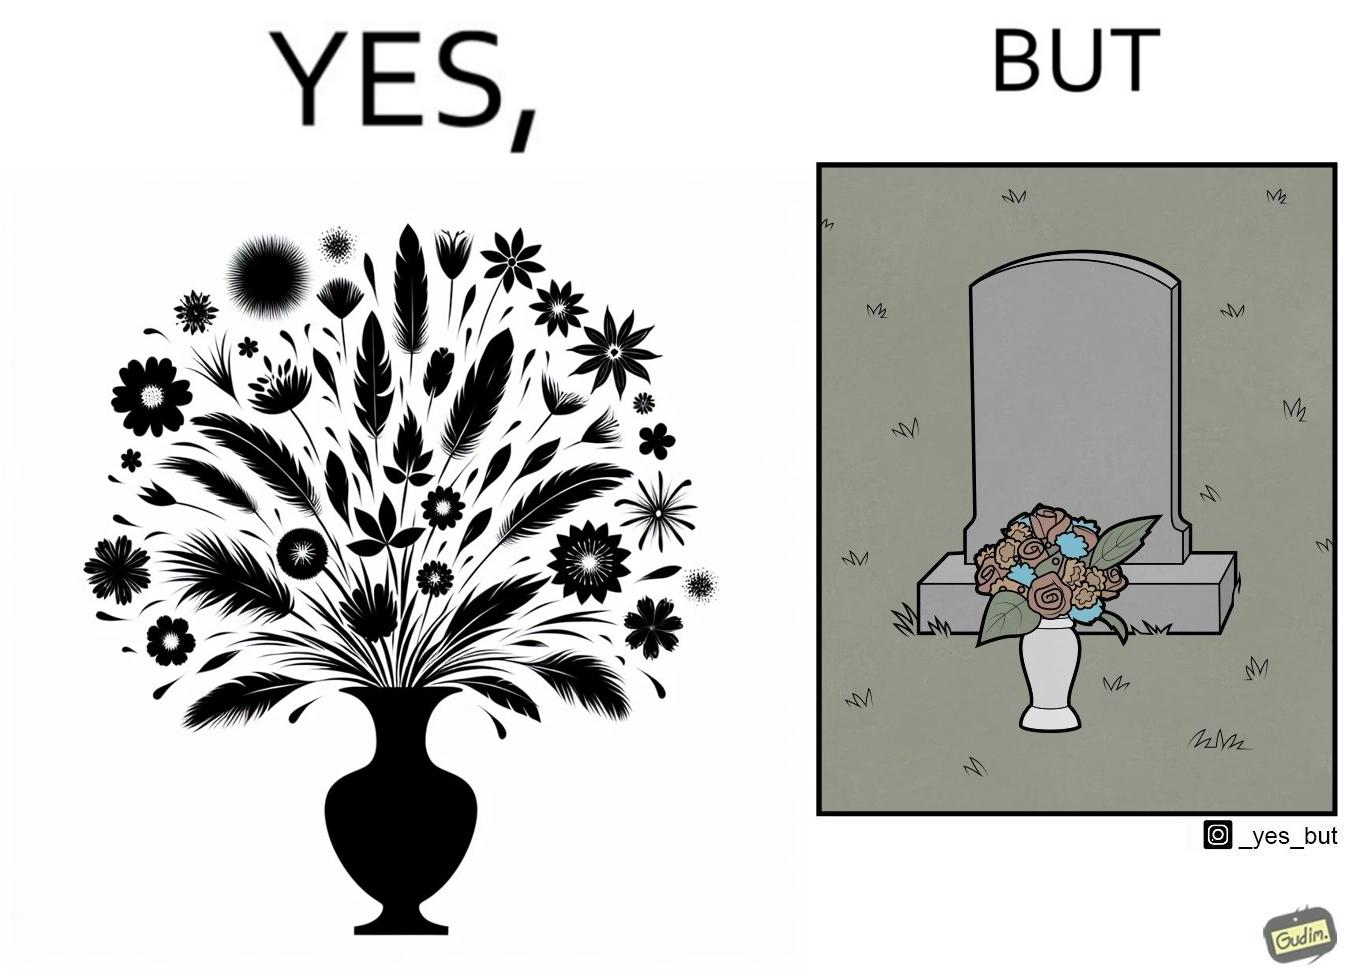Describe the contrast between the left and right parts of this image. In the left part of the image: a beautiful vase of full of different beautiful flowers In the right part of the image: a beautiful vase of full of different beautiful flowers put in front of someone's grave stone 